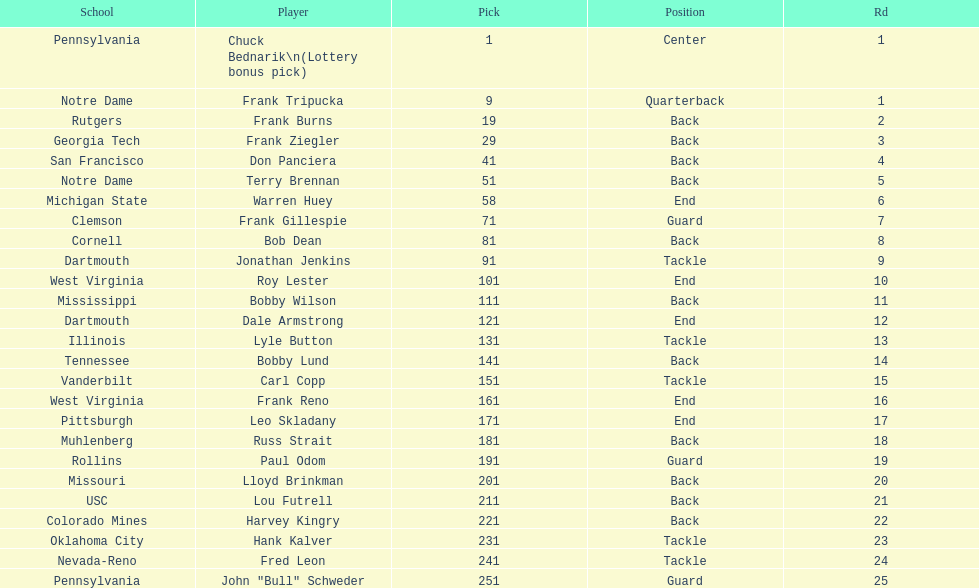After drafting bob dean, who was the next player chosen by the team? Jonathan Jenkins. 